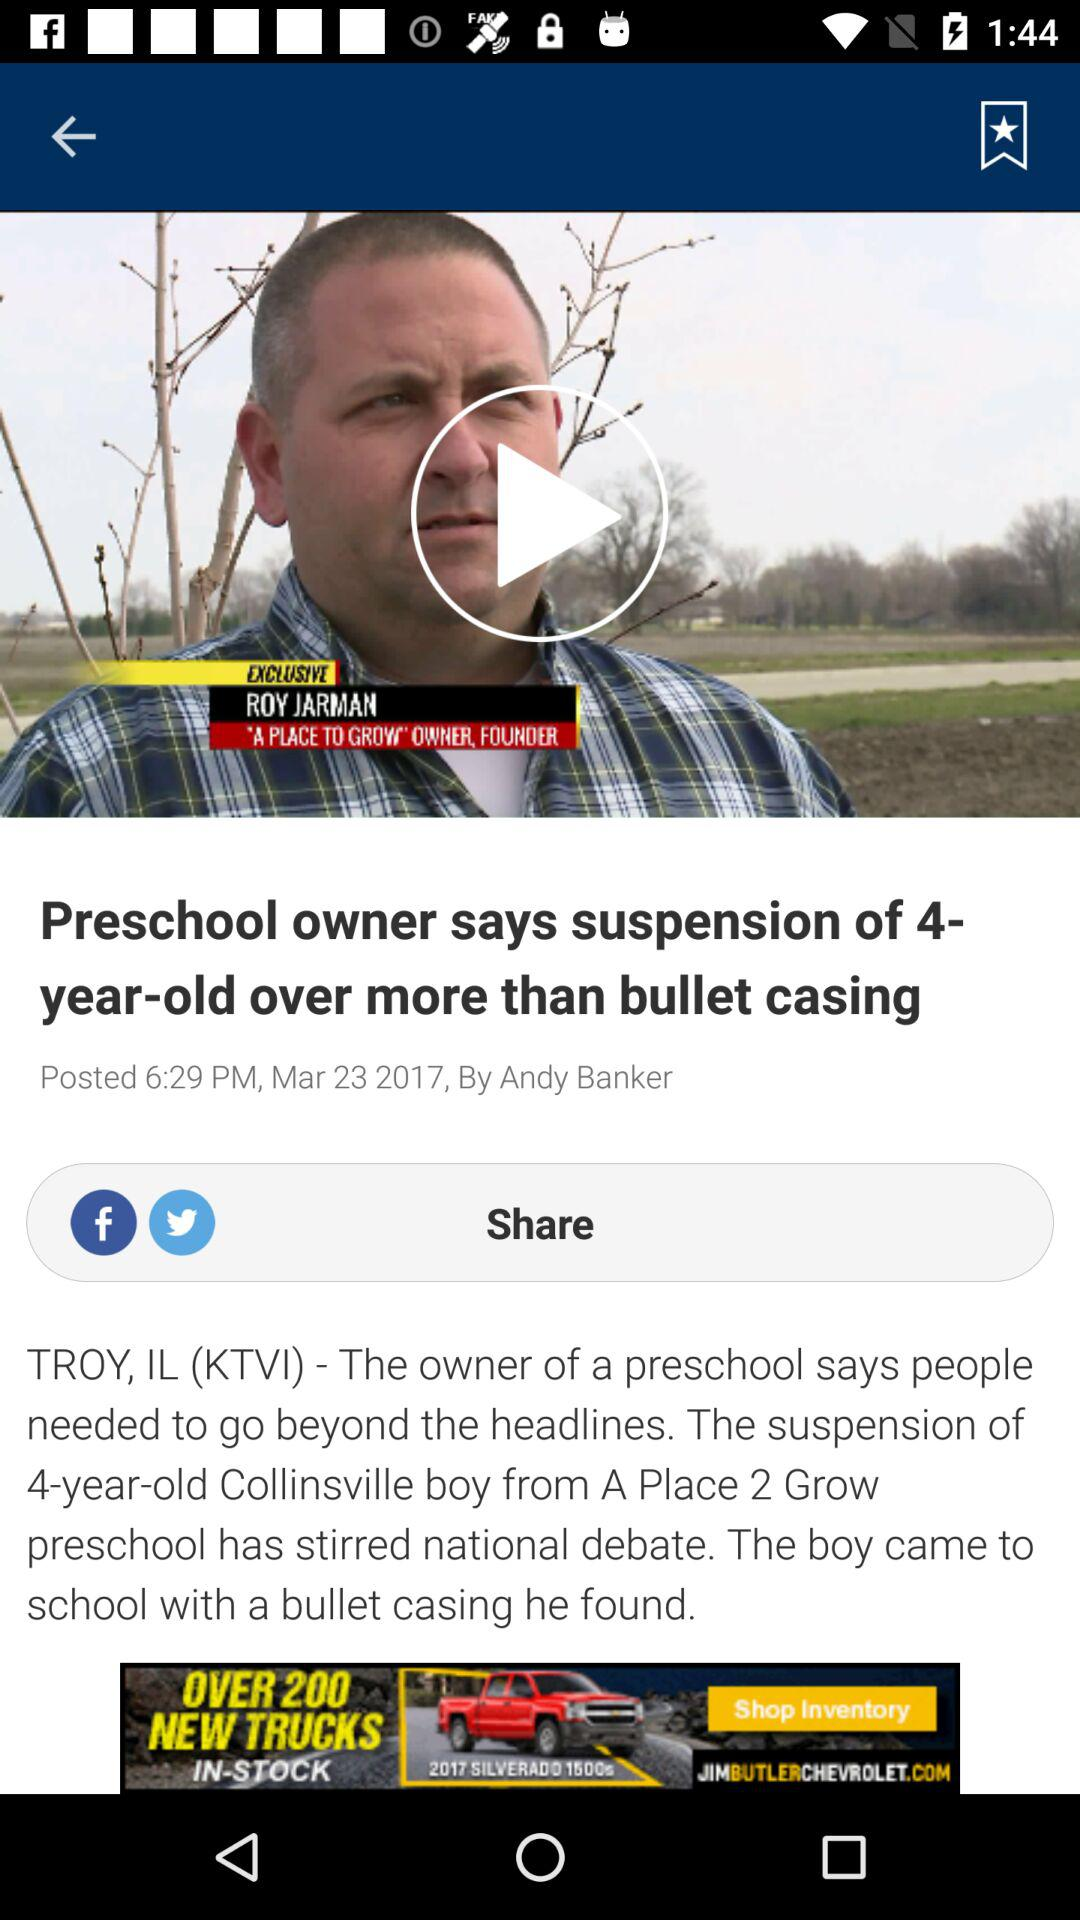On what date was the article posted? The article was posted on March 23, 2017. 